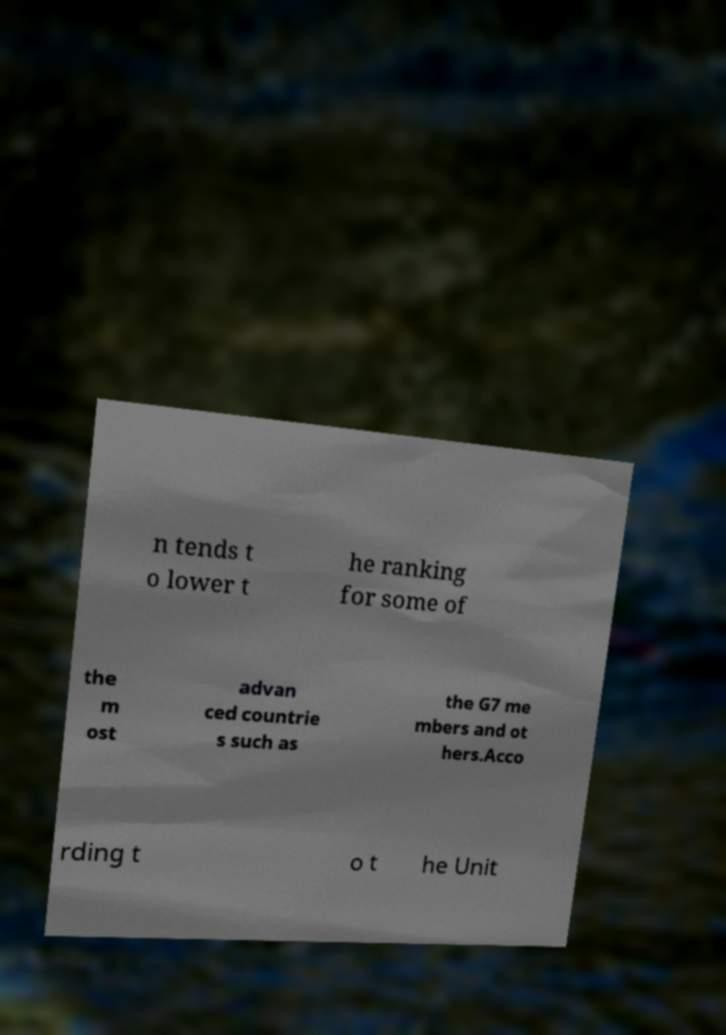Can you accurately transcribe the text from the provided image for me? n tends t o lower t he ranking for some of the m ost advan ced countrie s such as the G7 me mbers and ot hers.Acco rding t o t he Unit 